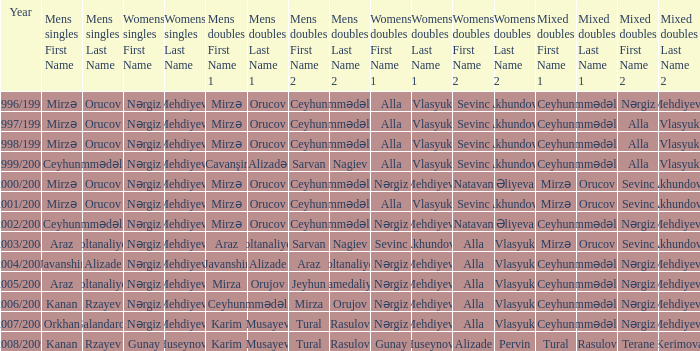Who are all the womens doubles for the year 2008/2009? Gunay Huseynova Alizade Pervin. 